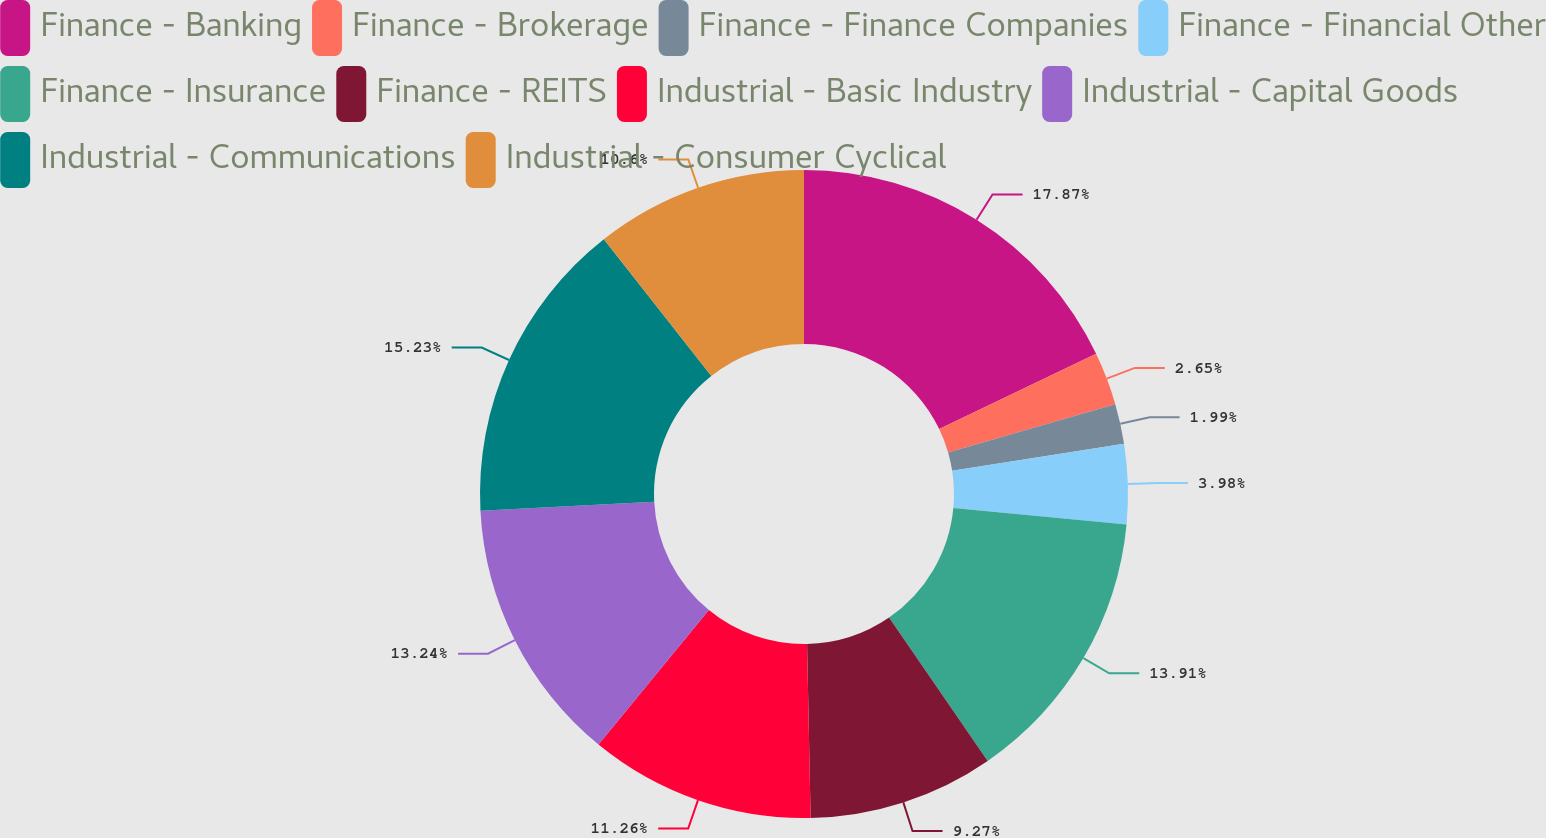Convert chart. <chart><loc_0><loc_0><loc_500><loc_500><pie_chart><fcel>Finance - Banking<fcel>Finance - Brokerage<fcel>Finance - Finance Companies<fcel>Finance - Financial Other<fcel>Finance - Insurance<fcel>Finance - REITS<fcel>Industrial - Basic Industry<fcel>Industrial - Capital Goods<fcel>Industrial - Communications<fcel>Industrial - Consumer Cyclical<nl><fcel>17.88%<fcel>2.65%<fcel>1.99%<fcel>3.98%<fcel>13.91%<fcel>9.27%<fcel>11.26%<fcel>13.24%<fcel>15.23%<fcel>10.6%<nl></chart> 